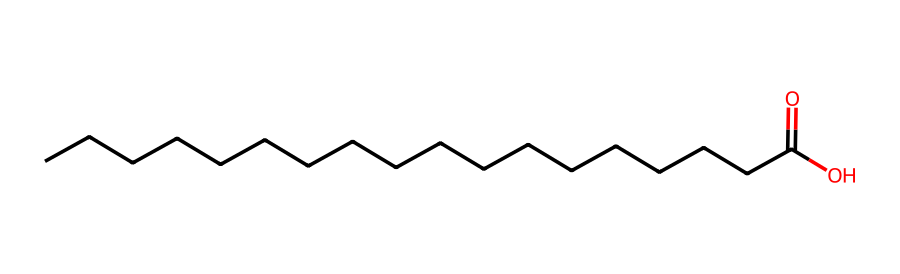What is the chemical name of this compound? The SMILES representation describes the structure clearly, which corresponds to stearic acid, a common fatty acid with a long carbon chain.
Answer: stearic acid How many carbon atoms are present in stearic acid? The structure indicates a long carbon chain, and counting the carbon atoms in the SMILES representation shows there are 18 carbon atoms.
Answer: 18 What type of functional group is present in this molecule? The SMILES representation ends with "O", indicating the presence of a carboxylic acid functional group due to the "C(=O)O" part.
Answer: carboxylic acid Is stearic acid soluble in water? As a non-electrolyte with a long hydrophobic carbon chain and a hydrophilic carboxylic group, stearic acid exhibits low solubility in water overall.
Answer: low Does stearic acid have any double bonds in its structure? The SMILES string indicates no double bonds between the carbon atoms in the chain, except the one in the carboxylic group; hence, it is fully saturated.
Answer: no What is the total number of hydrogen atoms in stearic acid? From the molecular formula C18H36O2 derived from the SMILES, there are 36 hydrogen atoms attached to the carbon backbone and the functional group.
Answer: 36 